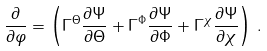<formula> <loc_0><loc_0><loc_500><loc_500>\frac { \partial } { \partial \varphi } = \left ( \Gamma ^ { \Theta } \frac { \partial \Psi } { \partial \Theta } + \Gamma ^ { \Phi } \frac { \partial \Psi } { \partial \Phi } + \Gamma ^ { \chi } \frac { \partial \Psi } { \partial \chi } \right ) \, .</formula> 